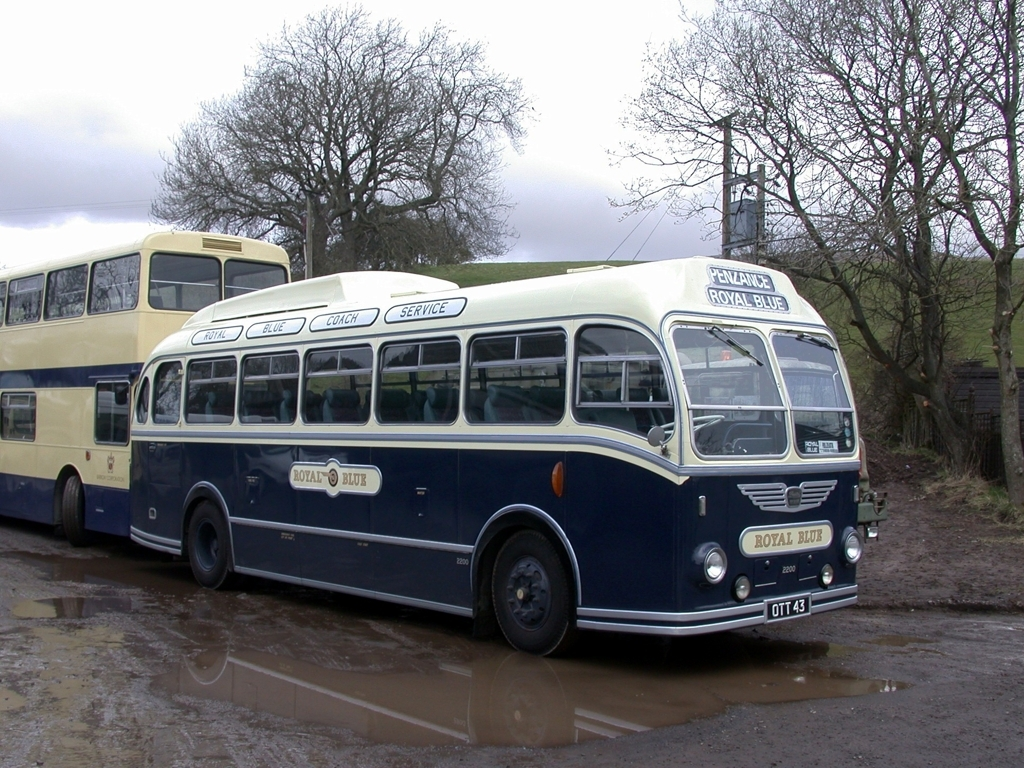Can you tell me more about the era these buses are from? Certainly! These buses resemble models from the mid-20th century, particularly from the 1950s to the 1960s. This was a time when such vehicles were a common sight in public transport, offering services to connect people across towns and countryside areas. 